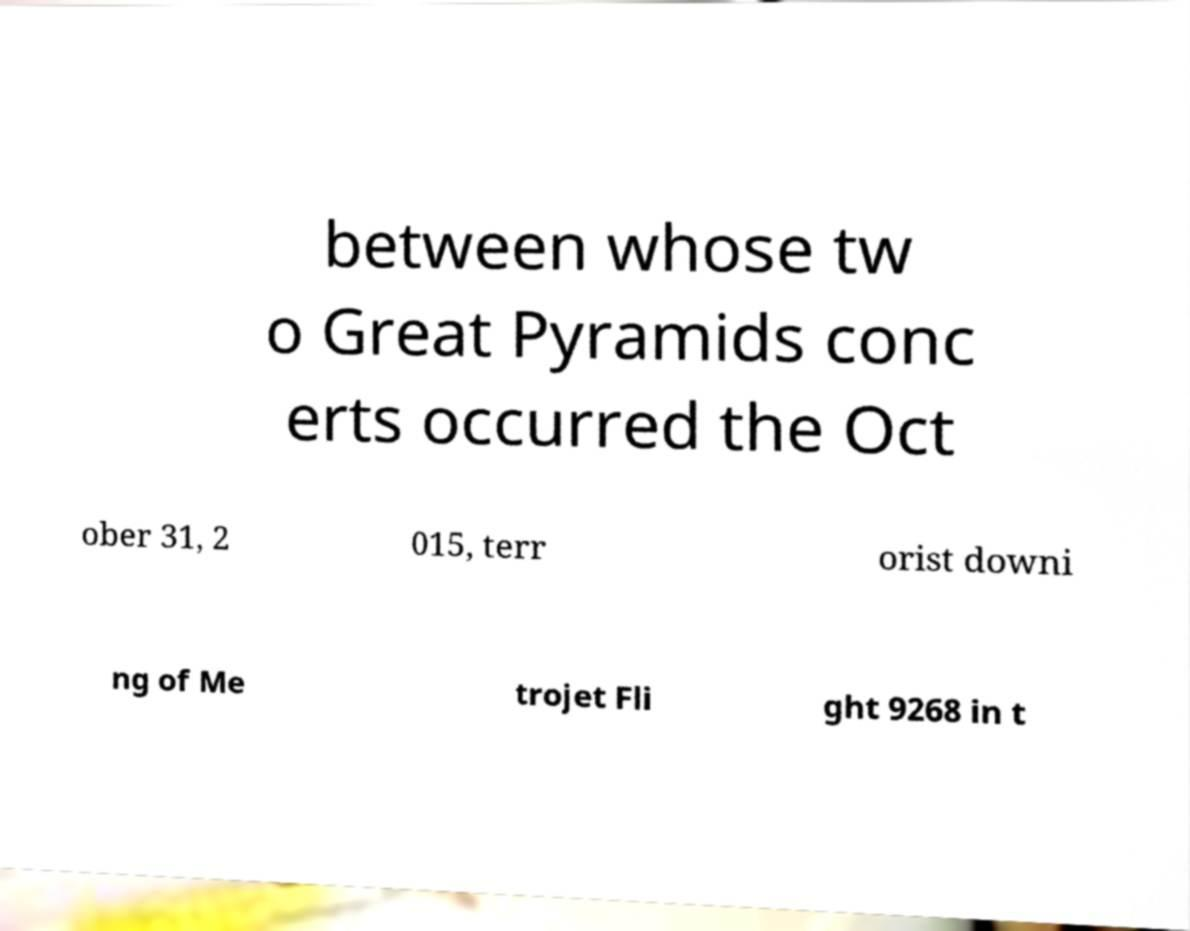Please identify and transcribe the text found in this image. between whose tw o Great Pyramids conc erts occurred the Oct ober 31, 2 015, terr orist downi ng of Me trojet Fli ght 9268 in t 